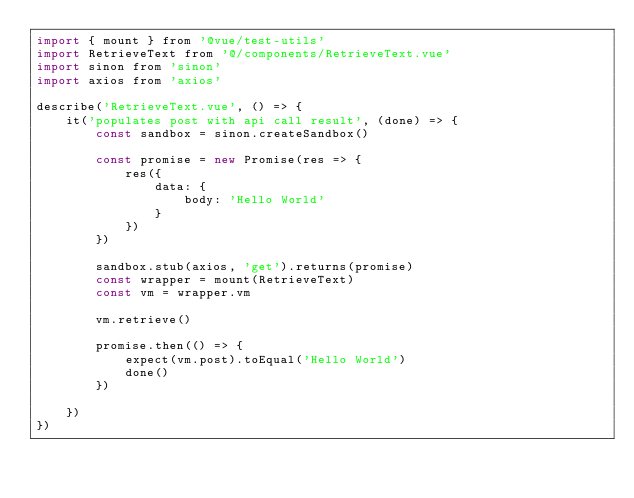<code> <loc_0><loc_0><loc_500><loc_500><_JavaScript_>import { mount } from '@vue/test-utils'
import RetrieveText from '@/components/RetrieveText.vue'
import sinon from 'sinon'
import axios from 'axios'

describe('RetrieveText.vue', () => {
    it('populates post with api call result', (done) => {
        const sandbox = sinon.createSandbox()

        const promise = new Promise(res => {
            res({
                data: {
                    body: 'Hello World'
                }
            })
        })

        sandbox.stub(axios, 'get').returns(promise)
        const wrapper = mount(RetrieveText)
        const vm = wrapper.vm

        vm.retrieve()

        promise.then(() => {
            expect(vm.post).toEqual('Hello World')
            done()
        })

    })
})</code> 